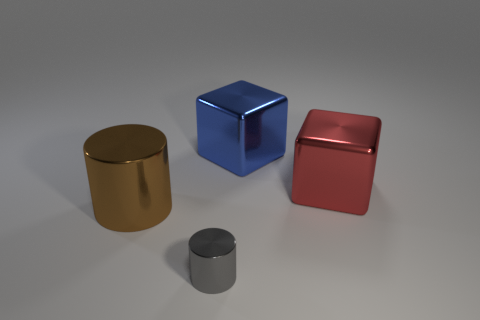What time of day does this lighting suggest if it were natural? If the lighting were natural, its diffused quality and the lack of harsh shadows might suggest an overcast day, where the sun is obscured by clouds, diffusing the light evenly. 